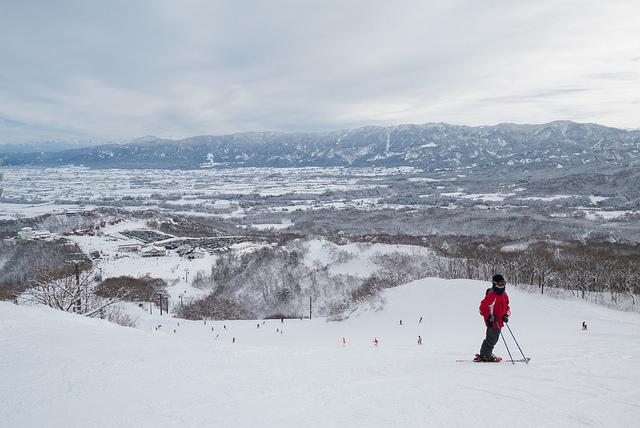Are they all skiing?
Concise answer only. Yes. What mountains are these?
Short answer required. Rockies. Is the man sweeping the snow?
Quick response, please. No. How many people are pictured?
Short answer required. 1. Is it sunny?
Short answer required. No. Where is this ski range?
Keep it brief. Colorado. Did the person fall down?
Keep it brief. No. 